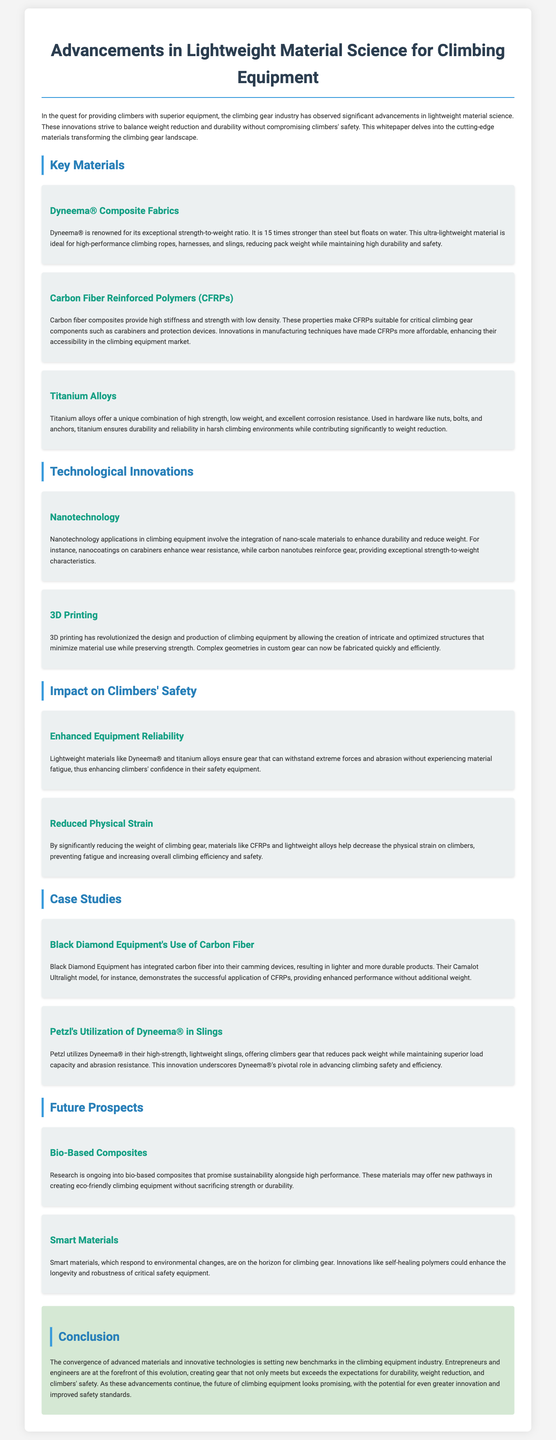What is the primary focus of the whitepaper? The primary focus of the whitepaper is on the advancements in lightweight material science for climbing equipment and how it balances weight reduction and durability without compromising safety.
Answer: Advancements in lightweight material science for climbing equipment What material is 15 times stronger than steel? The document states that Dyneema® is 15 times stronger than steel, making it ideal for high-performance climbing gear.
Answer: Dyneema® What are the key technologies mentioned in the whitepaper? The whitepaper mentions nanotechnology and 3D printing as key technological innovations in climbing equipment.
Answer: Nanotechnology and 3D printing Which company utilizes Dyneema® in their slings? Petzl is the company mentioned in the document that utilizes Dyneema® in their high-strength, lightweight slings.
Answer: Petzl What are bio-based composites researching to enhance? The document indicates that bio-based composites are researching to enhance sustainability while maintaining high performance.
Answer: Sustainability How do lightweight materials affect climbers physically? Lightweight materials help decrease the physical strain on climbers, preventing fatigue and increasing overall efficiency and safety.
Answer: Decrease physical strain What is the material used in Black Diamond's camming devices? Black Diamond Equipment integrates carbon fiber into their camming devices for lighter and more durable products.
Answer: Carbon fiber What future technology is mentioned that could improve safety equipment? The whitepaper mentions smart materials, including self-healing polymers, which could improve the longevity and robustness of safety equipment.
Answer: Smart materials What is emphasized in the conclusion of the whitepaper? The conclusion emphasizes that advancements in materials and technologies are setting new benchmarks in the climbing equipment industry, especially regarding durability and safety.
Answer: Durability and safety 